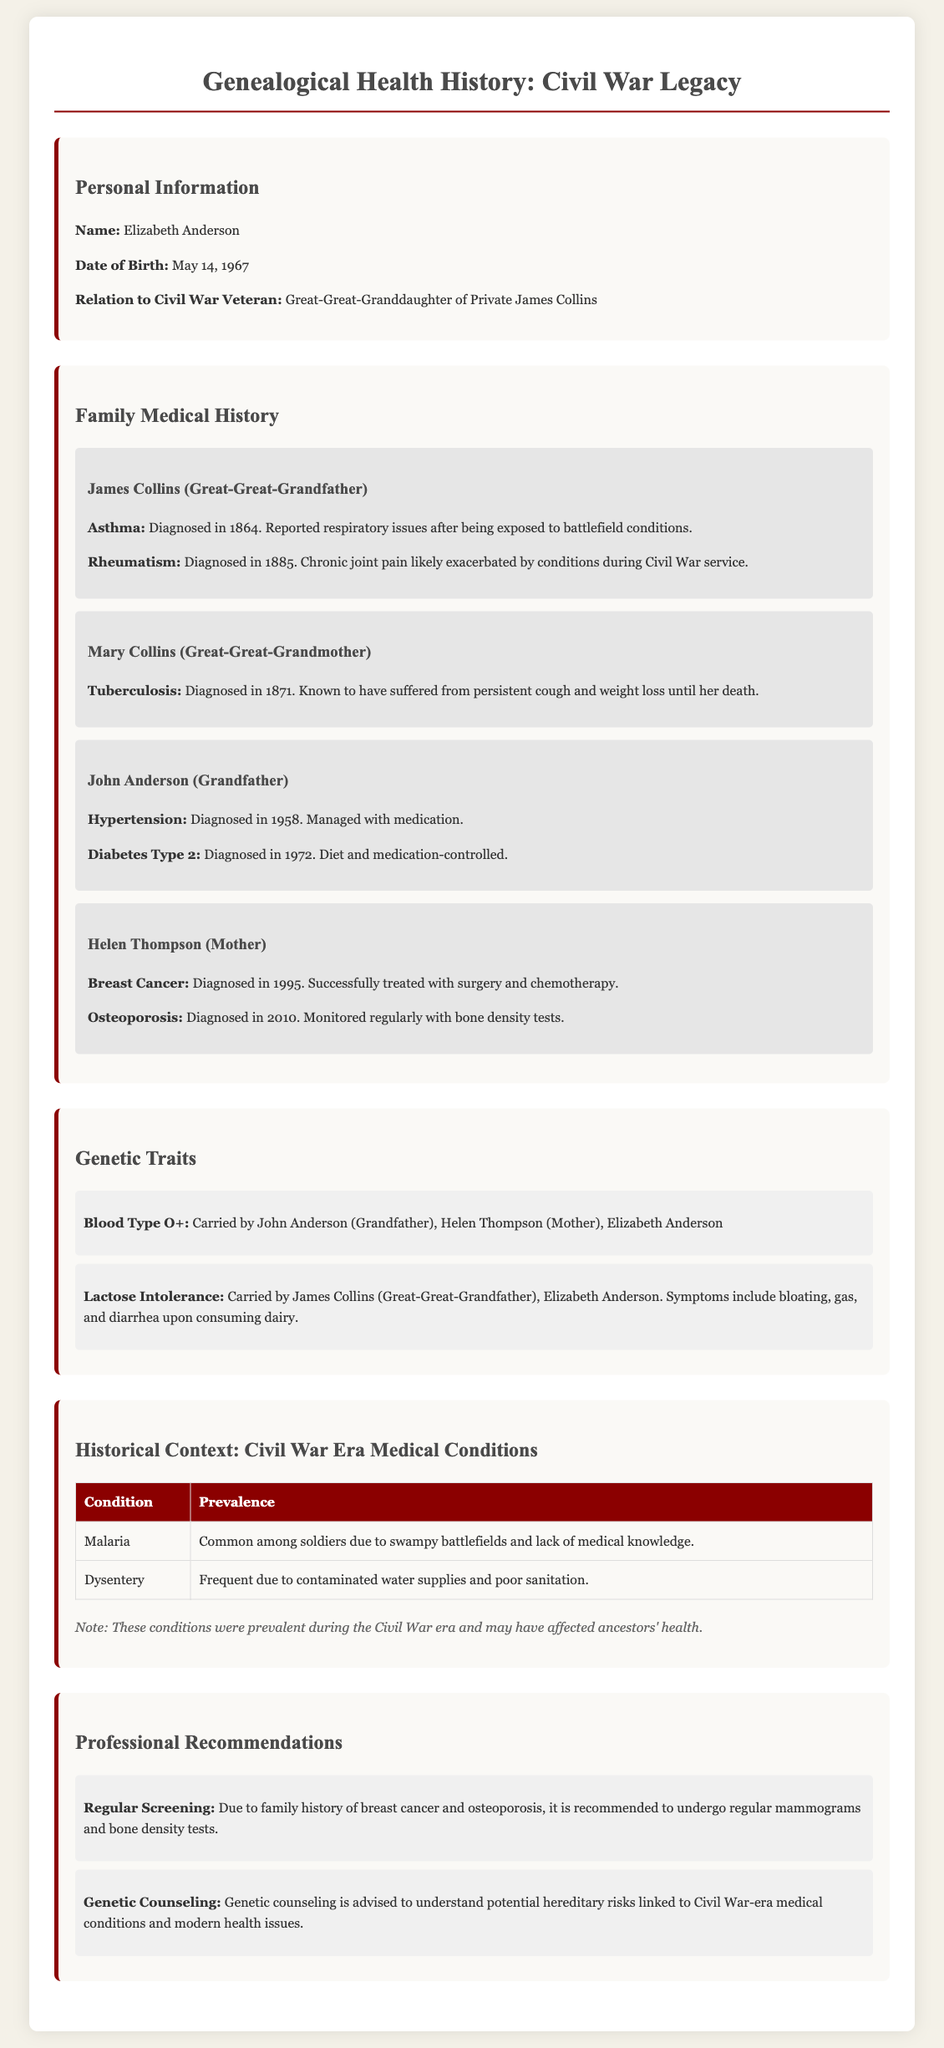what is the name of the individual whose medical history is documented? The name of the individual is stated in the Personal Information section of the document.
Answer: Elizabeth Anderson what is the relation of Elizabeth Anderson to the Civil War veteran? The document specifies the relation to highlight family lineage connected to the Civil War.
Answer: Great-Great-Granddaughter when was James Collins diagnosed with asthma? The diagnosis date is included in the Family Medical History section for clarity on historical health issues.
Answer: 1864 which family member underwent successful treatment for breast cancer? This information is important to understand the individual's family health conditions and treatments.
Answer: Helen Thompson what significant genetic trait does Elizabeth Anderson inherit related to lactose? The document notes specific traits passed down through the family, useful for understanding genetic predispositions.
Answer: Lactose Intolerance what recommendation is given for individuals with a family history of osteoporosis? Recommendations provide insights into preventive health measures crucial for family members.
Answer: Regular mammograms and bone density tests which condition was prevalent among soldiers during the Civil War due to poor sanitation? Understanding prevalent historical conditions helps contextualize the health issues faced by ancestors.
Answer: Dysentery what condition did John Anderson manage with medication? The document discusses various family health conditions, highlighting the management of chronic ailments.
Answer: Hypertension who was diagnosed with tuberculosis in 1871? This information specifies historical health conditions relevant to the family lineage.
Answer: Mary Collins 